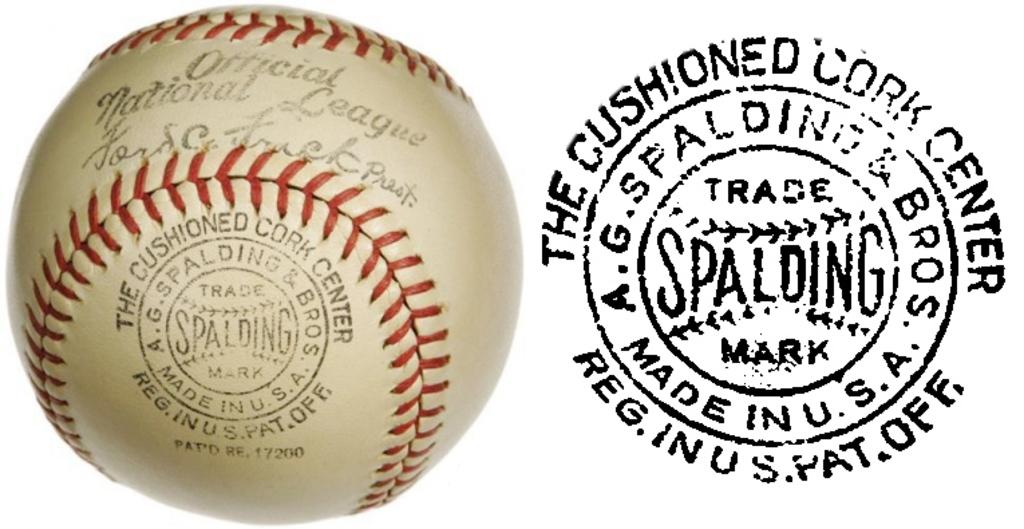Which country manufactured the ball in the picture?
Offer a terse response. Usa. What company manufactured this baseball?
Make the answer very short. Spalding. 